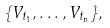<formula> <loc_0><loc_0><loc_500><loc_500>\{ V _ { t _ { 1 } } , \dots , V _ { t _ { n } } \} ,</formula> 